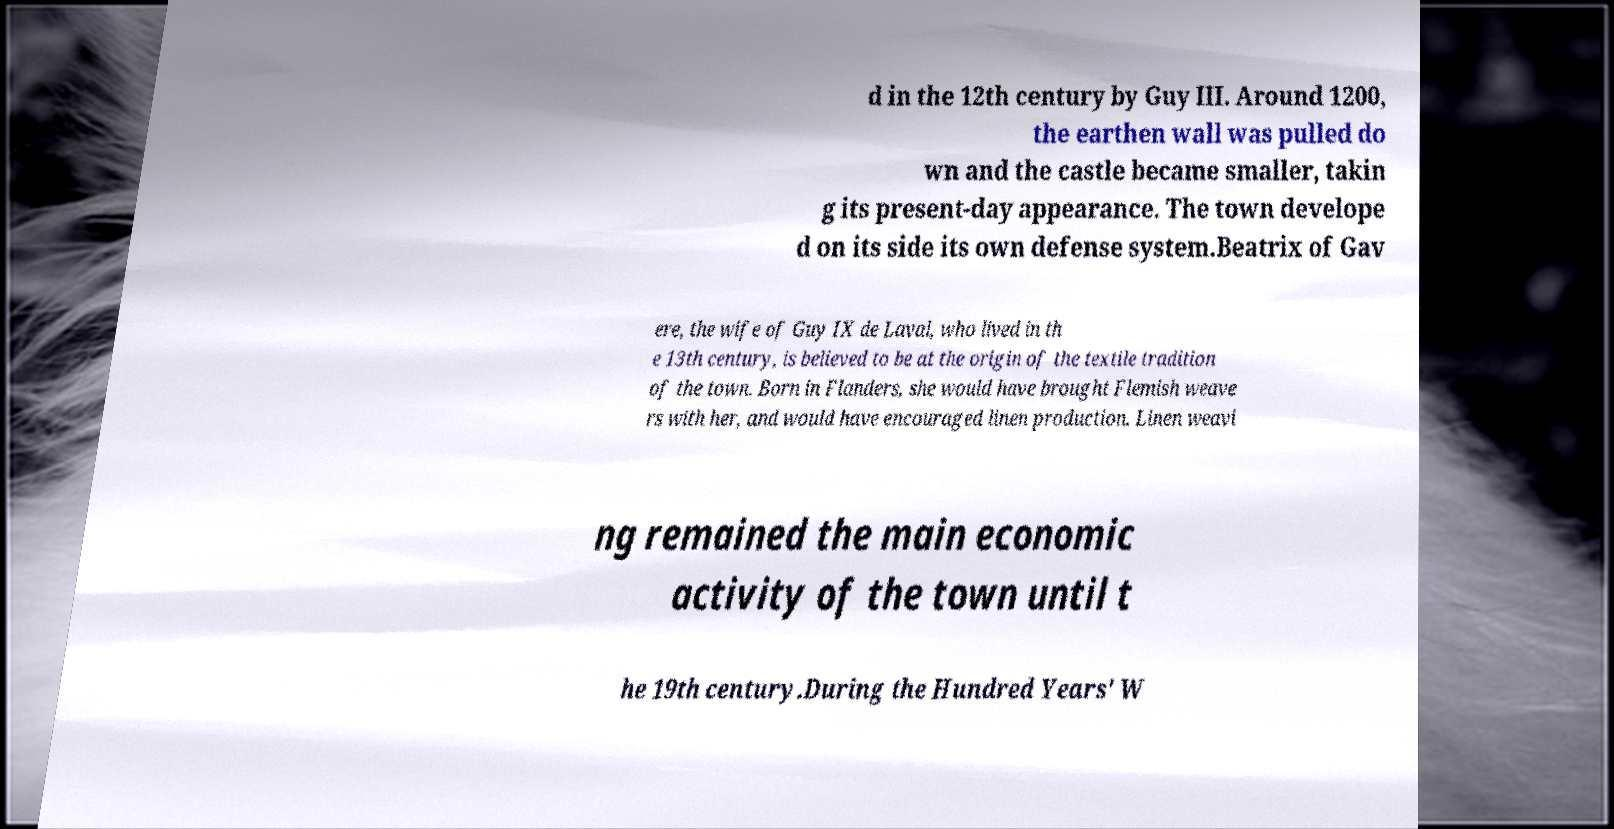Can you read and provide the text displayed in the image?This photo seems to have some interesting text. Can you extract and type it out for me? d in the 12th century by Guy III. Around 1200, the earthen wall was pulled do wn and the castle became smaller, takin g its present-day appearance. The town develope d on its side its own defense system.Beatrix of Gav ere, the wife of Guy IX de Laval, who lived in th e 13th century, is believed to be at the origin of the textile tradition of the town. Born in Flanders, she would have brought Flemish weave rs with her, and would have encouraged linen production. Linen weavi ng remained the main economic activity of the town until t he 19th century.During the Hundred Years' W 